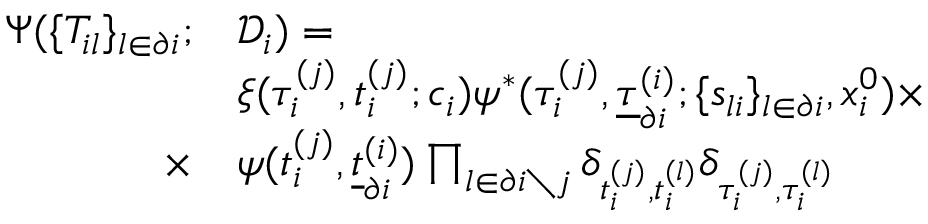<formula> <loc_0><loc_0><loc_500><loc_500>\begin{array} { r } { \begin{array} { r l } { \Psi ( \{ T _ { i l } \} _ { l \in \partial i } ; } & { \mathcal { D } _ { i } ) = } \\ & { \xi ( \tau _ { i } ^ { ( j ) } , t _ { i } ^ { ( j ) } ; c _ { i } ) \psi ^ { * } ( \tau _ { i } ^ { ( j ) } , \underline { \tau } _ { \partial i } ^ { ( i ) } ; \{ s _ { l i } \} _ { l \in \partial i } , x _ { i } ^ { 0 } ) \times } \\ { \times } & { \psi ( t _ { i } ^ { ( j ) } , \underline { t } _ { \partial i } ^ { ( i ) } ) \prod _ { l \in \partial i \ j } \delta _ { t _ { i } ^ { ( j ) } , t _ { i } ^ { ( l ) } } \delta _ { \tau _ { i } ^ { ( j ) } , \tau _ { i } ^ { ( l ) } } } \end{array} } \end{array}</formula> 